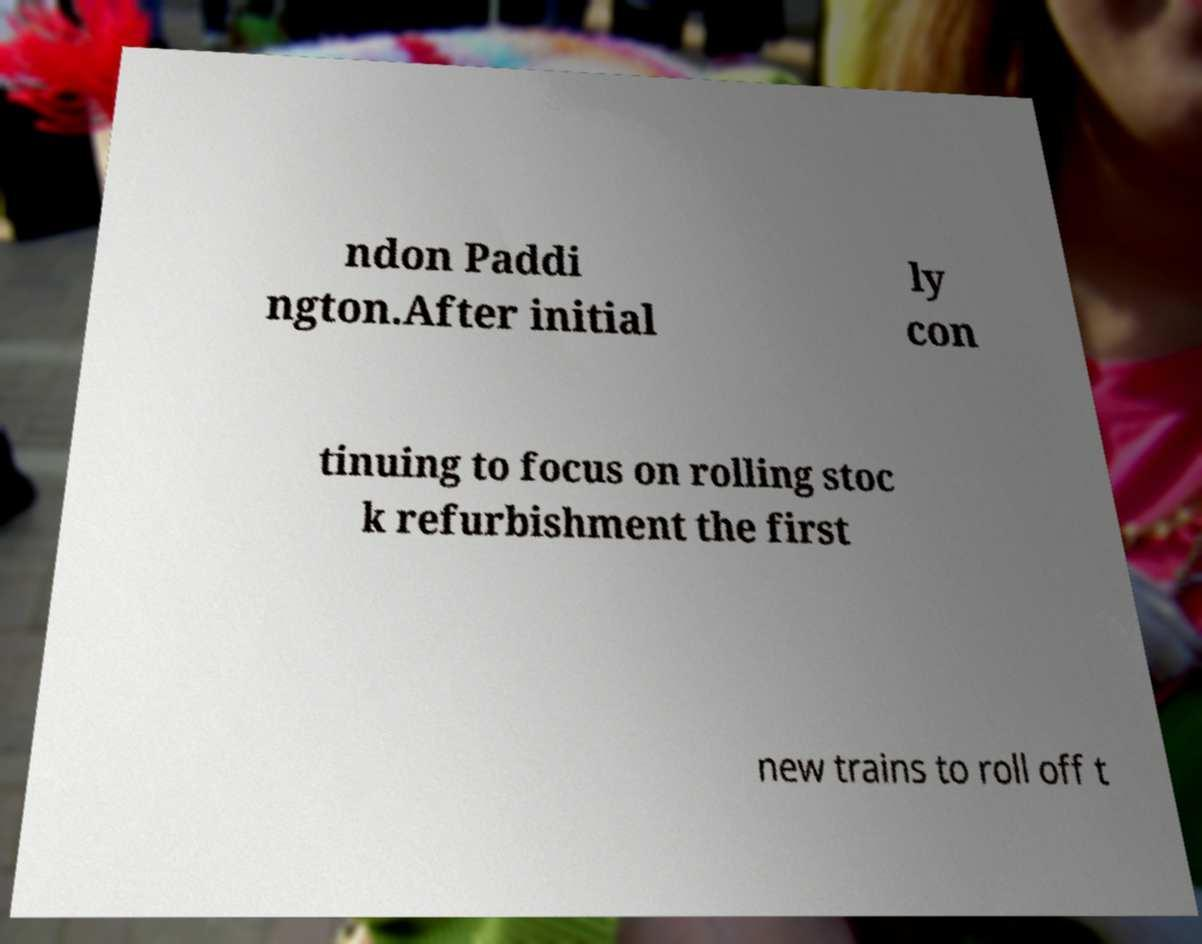For documentation purposes, I need the text within this image transcribed. Could you provide that? ndon Paddi ngton.After initial ly con tinuing to focus on rolling stoc k refurbishment the first new trains to roll off t 